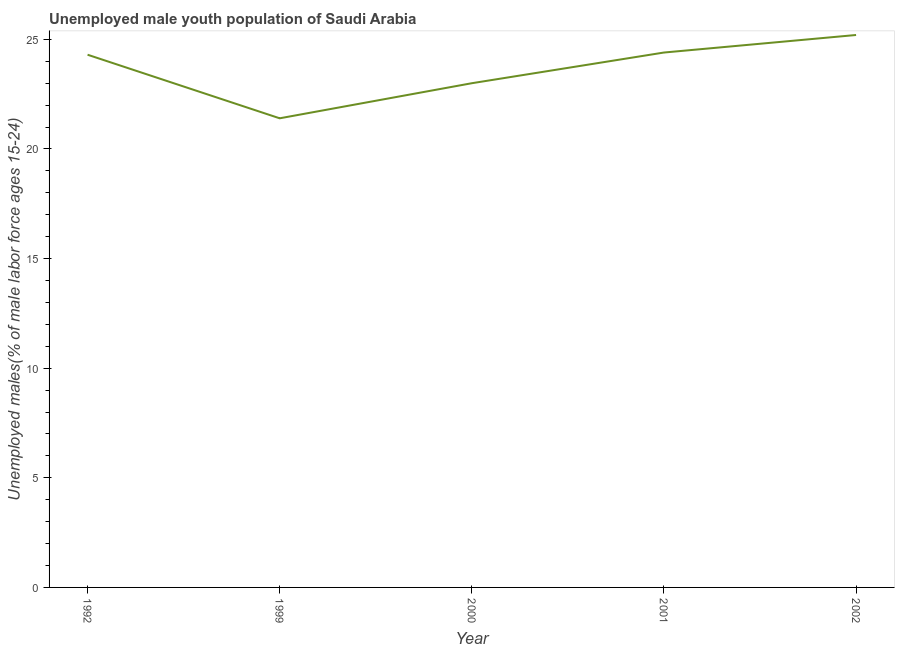What is the unemployed male youth in 2002?
Ensure brevity in your answer.  25.2. Across all years, what is the maximum unemployed male youth?
Your response must be concise. 25.2. Across all years, what is the minimum unemployed male youth?
Keep it short and to the point. 21.4. In which year was the unemployed male youth maximum?
Give a very brief answer. 2002. In which year was the unemployed male youth minimum?
Keep it short and to the point. 1999. What is the sum of the unemployed male youth?
Your answer should be compact. 118.3. What is the difference between the unemployed male youth in 1999 and 2002?
Give a very brief answer. -3.8. What is the average unemployed male youth per year?
Provide a short and direct response. 23.66. What is the median unemployed male youth?
Your answer should be compact. 24.3. In how many years, is the unemployed male youth greater than 14 %?
Provide a short and direct response. 5. Do a majority of the years between 2001 and 1992 (inclusive) have unemployed male youth greater than 6 %?
Your answer should be compact. Yes. What is the ratio of the unemployed male youth in 1999 to that in 2002?
Offer a very short reply. 0.85. What is the difference between the highest and the second highest unemployed male youth?
Offer a terse response. 0.8. Is the sum of the unemployed male youth in 1999 and 2000 greater than the maximum unemployed male youth across all years?
Your response must be concise. Yes. What is the difference between the highest and the lowest unemployed male youth?
Your answer should be very brief. 3.8. What is the difference between two consecutive major ticks on the Y-axis?
Your answer should be compact. 5. Are the values on the major ticks of Y-axis written in scientific E-notation?
Keep it short and to the point. No. Does the graph contain any zero values?
Your answer should be very brief. No. What is the title of the graph?
Your answer should be compact. Unemployed male youth population of Saudi Arabia. What is the label or title of the Y-axis?
Provide a short and direct response. Unemployed males(% of male labor force ages 15-24). What is the Unemployed males(% of male labor force ages 15-24) of 1992?
Provide a succinct answer. 24.3. What is the Unemployed males(% of male labor force ages 15-24) of 1999?
Provide a short and direct response. 21.4. What is the Unemployed males(% of male labor force ages 15-24) in 2001?
Your response must be concise. 24.4. What is the Unemployed males(% of male labor force ages 15-24) in 2002?
Provide a short and direct response. 25.2. What is the difference between the Unemployed males(% of male labor force ages 15-24) in 1992 and 1999?
Keep it short and to the point. 2.9. What is the difference between the Unemployed males(% of male labor force ages 15-24) in 1992 and 2001?
Provide a short and direct response. -0.1. What is the difference between the Unemployed males(% of male labor force ages 15-24) in 1992 and 2002?
Offer a very short reply. -0.9. What is the difference between the Unemployed males(% of male labor force ages 15-24) in 1999 and 2001?
Keep it short and to the point. -3. What is the difference between the Unemployed males(% of male labor force ages 15-24) in 2001 and 2002?
Offer a terse response. -0.8. What is the ratio of the Unemployed males(% of male labor force ages 15-24) in 1992 to that in 1999?
Offer a terse response. 1.14. What is the ratio of the Unemployed males(% of male labor force ages 15-24) in 1992 to that in 2000?
Offer a very short reply. 1.06. What is the ratio of the Unemployed males(% of male labor force ages 15-24) in 1992 to that in 2002?
Your response must be concise. 0.96. What is the ratio of the Unemployed males(% of male labor force ages 15-24) in 1999 to that in 2001?
Your response must be concise. 0.88. What is the ratio of the Unemployed males(% of male labor force ages 15-24) in 1999 to that in 2002?
Give a very brief answer. 0.85. What is the ratio of the Unemployed males(% of male labor force ages 15-24) in 2000 to that in 2001?
Provide a short and direct response. 0.94. What is the ratio of the Unemployed males(% of male labor force ages 15-24) in 2000 to that in 2002?
Ensure brevity in your answer.  0.91. 